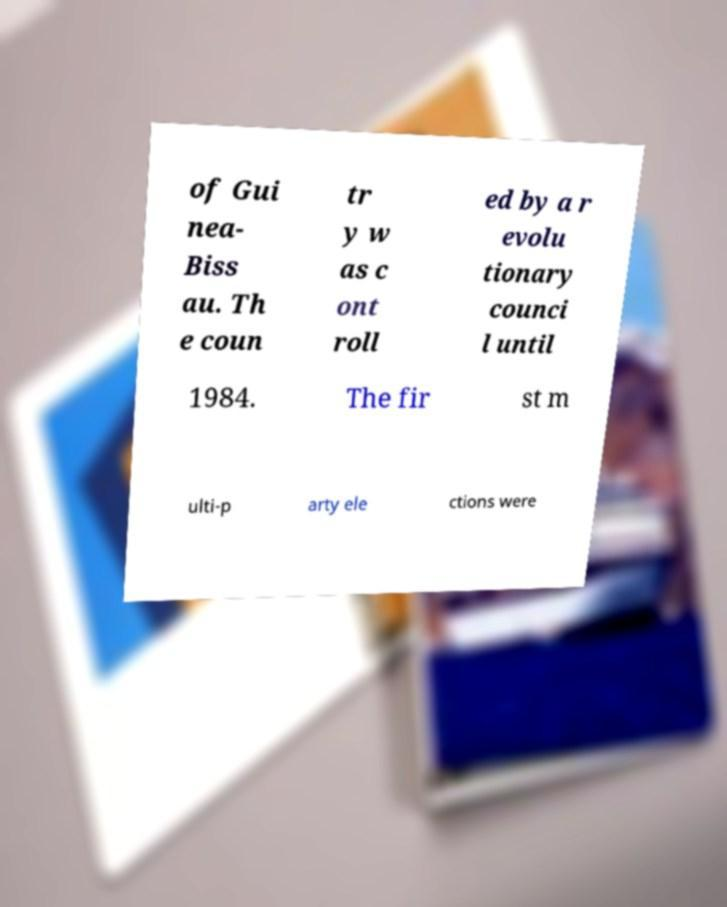Can you read and provide the text displayed in the image?This photo seems to have some interesting text. Can you extract and type it out for me? of Gui nea- Biss au. Th e coun tr y w as c ont roll ed by a r evolu tionary counci l until 1984. The fir st m ulti-p arty ele ctions were 